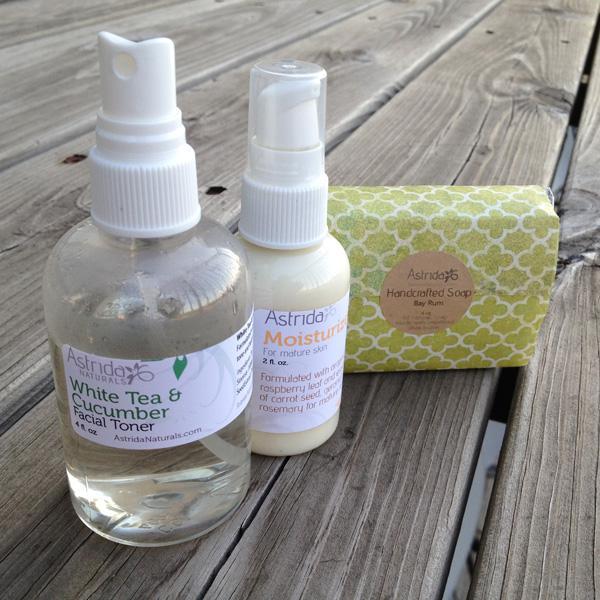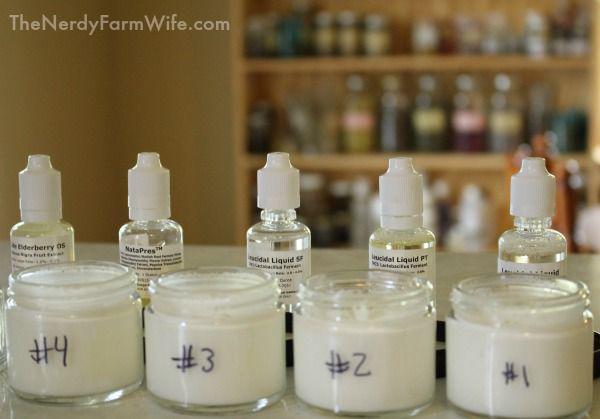The first image is the image on the left, the second image is the image on the right. Evaluate the accuracy of this statement regarding the images: "At least one container is open.". Is it true? Answer yes or no. Yes. The first image is the image on the left, the second image is the image on the right. Examine the images to the left and right. Is the description "In at least one image there is a total of five fragrance bottle with closed white caps." accurate? Answer yes or no. Yes. 